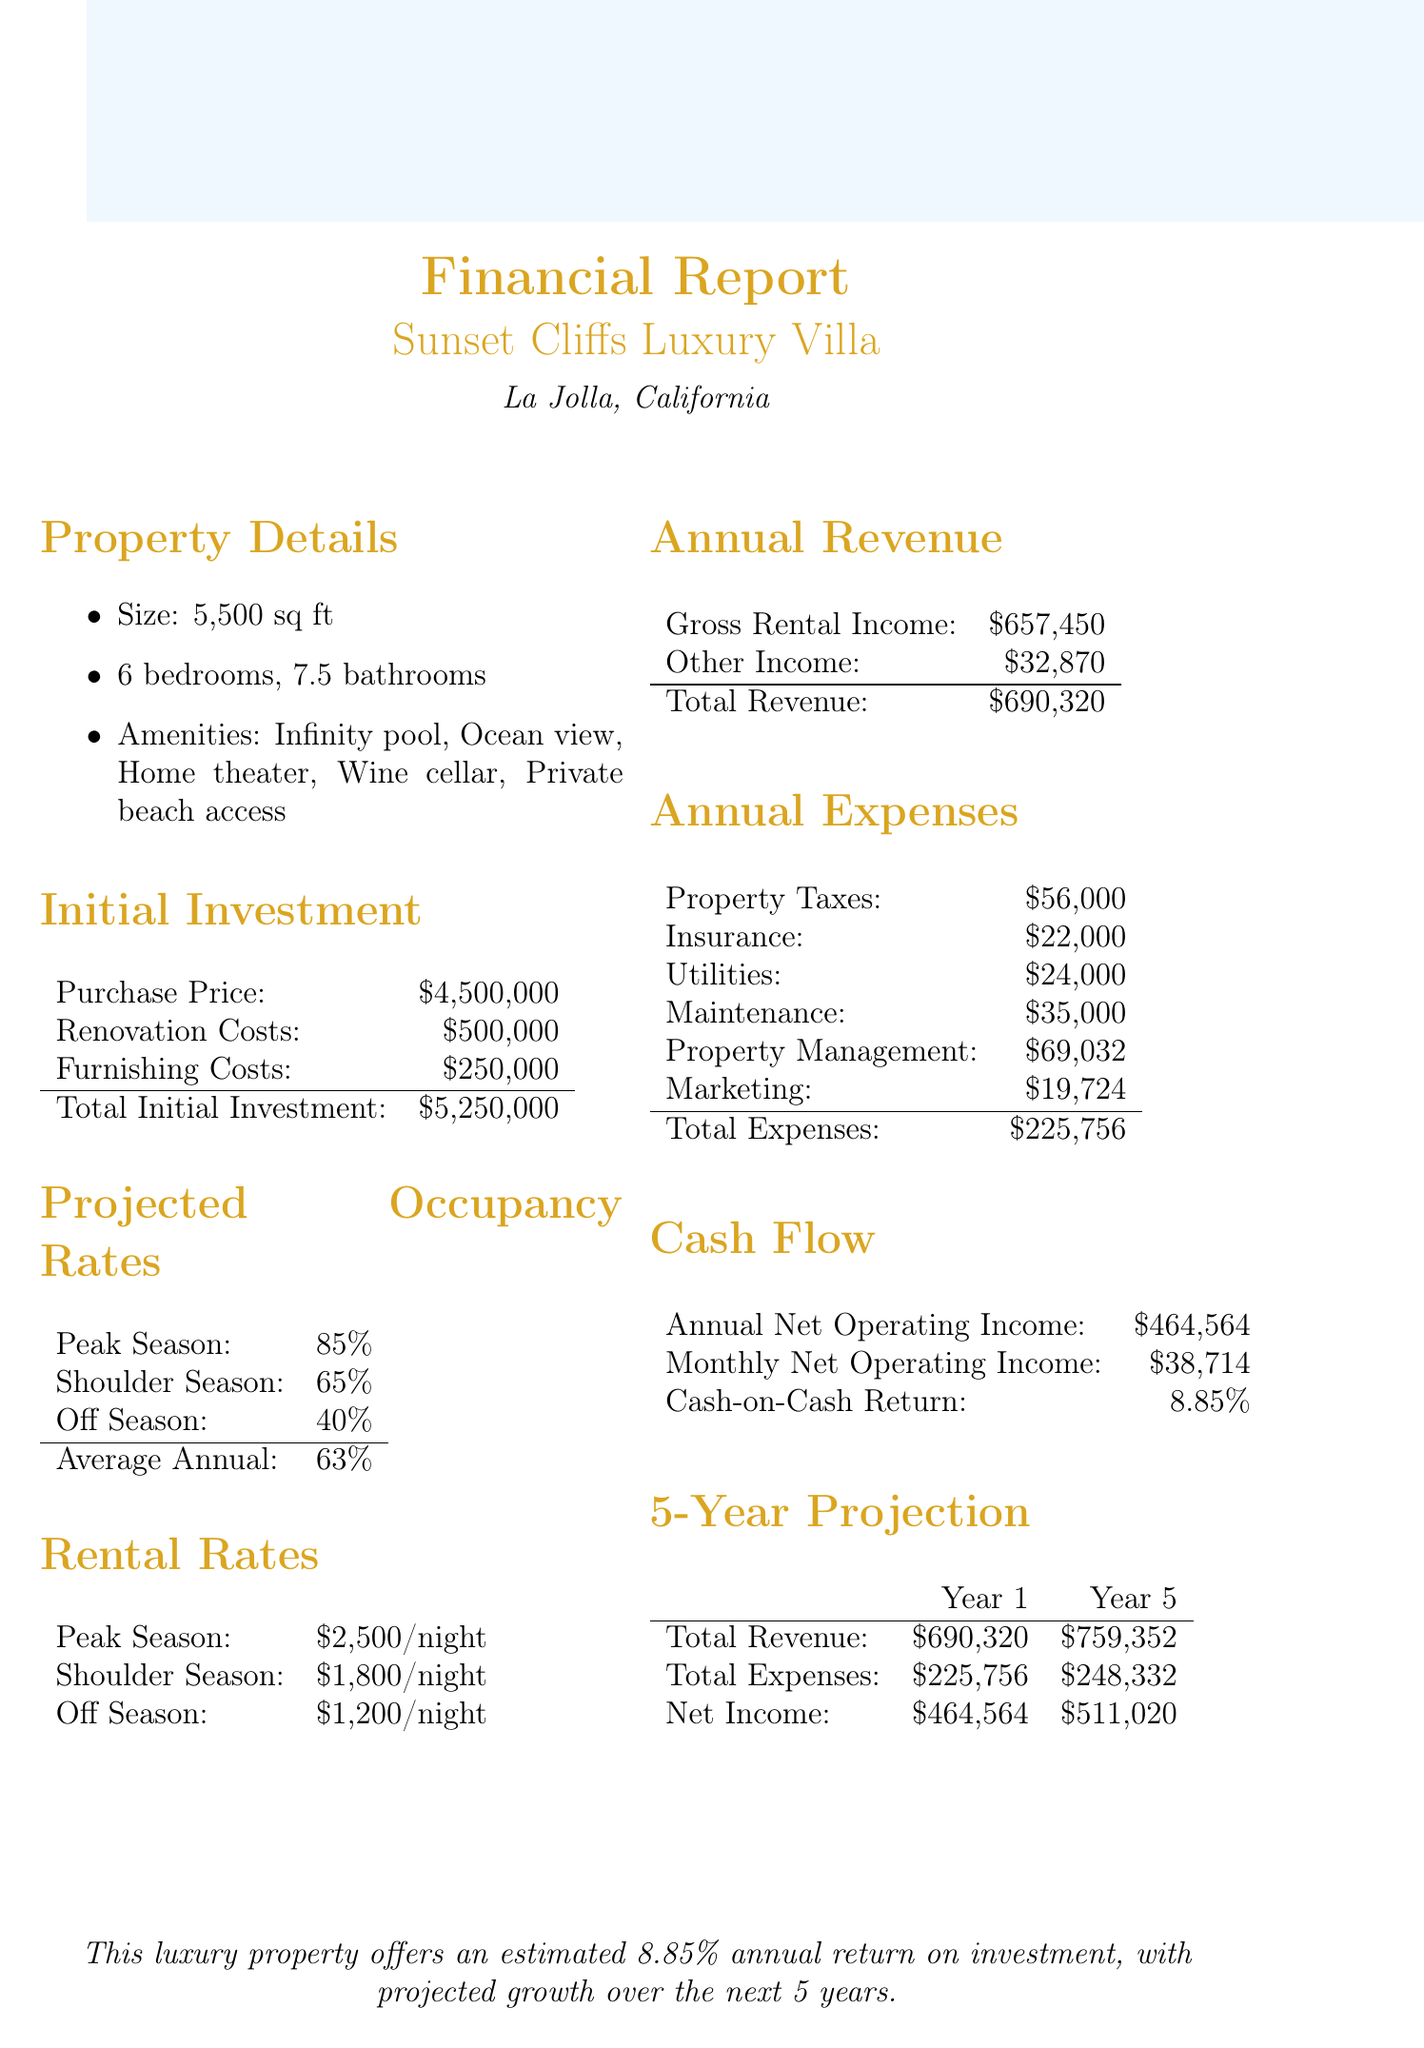What is the total initial investment? The total initial investment is listed in the document as the sum of the purchase price, renovation costs, and furnishing costs.
Answer: $5,250,000 What is the peak season occupancy rate? The peak season occupancy rate is specified in the document under projected occupancy rates.
Answer: 85% What amenities does the property offer? A list of amenities is provided in the property details section, highlighting the features available at the villa.
Answer: Infinity pool, Ocean view, Home theater, Wine cellar, Private beach access What is the annual net operating income? The annual net operating income is clearly outlined in the cash flow section of the document.
Answer: $464,564 What is the cash-on-cash return? The cash-on-cash return is mentioned in the cash flow section and indicates the investment's return.
Answer: 8.85% What are the total expenses for year 1? Total expenses for year 1 are provided in the 5-year projection table, showing the costs incurred during that year.
Answer: $225,756 What is the projected net income for year 5? The projected net income for year 5 is provided in the document as part of the financial projections.
Answer: $511,020 What is the average annual occupancy rate? The average annual occupancy rate is calculated based on the rates provided in the projected occupancy rates section.
Answer: 63% What is the gross rental income? The gross rental income is specified in the annual revenue section, detailing the income generated from renting the property.
Answer: $657,450 What is the monthly net operating income? The monthly net operating income is listed in the cash flow section, indicating monthly earnings after expenses.
Answer: $38,714 